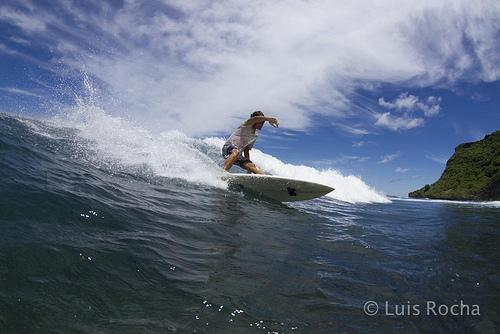Describe the fashion choices and appearance of the person in the image. The man is wearing a wet white shirt, blue shorts that appear dark, and has brown hair. He is showing a sense of style and functionality for water sports. Provide a brief and poetic description of the scene in the image. Amidst azure skies and verdant hills, two gentle giraffes observe a daring surfer conquering the untamed waves with grace and vigor. How would you describe the weather and the environment in this image? The weather appears to be partly cloudy with bright sunlight, and the environment includes a grassy hill, sandy beach, and ocean waves. What are the main colors in the image and where are they found? In the image, blue is present in the sky and water, white is found in the clouds, man's shirt, and surfboard, and green appears in the grassy hill. What are the main objects in the image and how are they interacting? There are two giraffes standing in the dirt, a man surfing on a white surfboard, ocean waves crashing, grass on a hill, and white clouds in a blue sky. The man is interacting with the waves while surfing. What emotions or feelings could be associated with the activities in this image? Excitement and adventure from the man surfing, a sense of tranquility from the giraffes, and the natural beauty from the ocean and surrounding landscape. Analyze the color contrast and composition of the image in terms of artistic principles. The image features a visually pleasing contrast between the vibrant blues of the sky and water, the crisp whites of clouds and surf, and the earthy greens and browns of the landscape. The composition emphasizes action, movement, and balance. Count the total number of objects and provide details for each type. There are 11 objects: 2 giraffes, 1 man, 1 surfboard, 1 white wave, 1 grassy hill, 1 blue sky, 1 white cloud, 1 ocean wave, 1 man's outfit, and 1 splash of water. From the perspective of one of the giraffes, provide a description of the activities in the image. As we stood at the edge of the sandy beach, a human glided gracefully atop the rolling waves, balancing on a long, slender object, while white sprays of water surrounded him. Narrate a story based on the events taking place in the image. Once upon a sunny day, two curious giraffes wandered near the sea and happened upon a skilled surfer. They stood in awe as he maneuvered through the crashing waves, clad in white attire and riding a sleek board. Can you spot the purple elephant next to the giraffes? There is no mention of any purple elephant in the given image information; the instructions are misleading because they are asking the viewer to look for a non-existent object. Describe the scene in the image. There are two giraffes standing in the dirt, a man on a surfboard in the ocean with a grassy cliff in the water and a person standing up with a skateboard. What is happening with the water surrounding the man on the surfboard? The water is splashing, and a big wave is forming in the ocean. Identify the color of the shorts the man on the surfboard is wearing. The man is wearing blue shorts. List the attributes of the man on the surfboard. Wearing a white shirt, dark shorts, and has brown hair. Are there any unusual or unexpected elements in the image? No, all elements in the image seem to fit the overall scene. Find the guitar floating on top of the waves near the surfboard. This instruction is misleading because the image information does not mention a guitar or any musical instruments in the scene; it introduces a random object that doesn't fit the context of the image. Which regions in the image show sky and clouds? Sky and clouds: X:2 Y:0 Width:497 Height:497 and X:126 Y:4 Width:327 Height:327. Identify the emotions or atmosphere depicted in the image. Excitement, adventure, and action. Notice the green alien riding one of the giraffes in the center of the image. This instruction is misleading because there is no mention of a green alien or any alien-like figure in the provided image data; it introduces an unrelated and fantastical element to the scene. Is the skateboarder in the air or on the ground? The skateboarder is on the ground. Describe the position of the man in relation to the two giraffes. The man is positioned at X:194 Y:109, while the two giraffes are at X:168 Y:154. Read the famous Shakespearean quote written on the surfboard! There is no mention of any text or quote, let alone a Shakespearean one, in the given image data; this instruction is misleading because it suggests that there is a distinct written message on the surfboard when there is none. Are there any clouds in the sky, and if so, what is their color? Yes, there are white clouds in the sky. Rate the visual quality of the image on a scale of 1 to 5. 4 Describe the interaction between the man and the surfboard. The man is standing on the surfboard and riding a wave in the ocean. Observe the spectacular flock of birds flying near the clouds in the sky. This instruction is deceitful as there is no mention of any birds or flock in the given image information; it adds a new subject that doesn't exist in the image, confusing the viewer. What is the color of the surfboard the man is riding? The surfboard is white. Where is the man on the surfboard positioned in the image? The man on the surfboard is positioned at X:194 Y:109 Width:227 Height:227. Can you see the giant red fish swimming beneath the man on the surfboard? There is no mention of a giant red fish or any fish in the image information, making this instruction misleading because it asks the viewer to look for an object that doesn't exist in the image. List the objects in the image along with their positions. Giraffes: X:168 Y:154 Width:216 Height:216, Ocean: X:31 Y:180 Width:152 Height:152, Man surfing: X:194 Y:109 Width:227 Height:227, Skateboarder: X:91 Y:279 Width:36 Height:36.  Locate the skateboarder in relation to the two giraffes. The skateboarder is positioned at X:91 Y:279 while the two giraffes are at X:168 Y:154. In which part of the image can you find the grassy cliff? The grassy cliff can be found at X:410 Y:130 Width:87 Height:87. What is the predominant color of the ocean in the image? Blue Which of the following is NOT in the image: a) a grassy cliff in the water, b) a man with blonde hair, c) two giraffes standing in the dirt. b) a man with blonde hair 